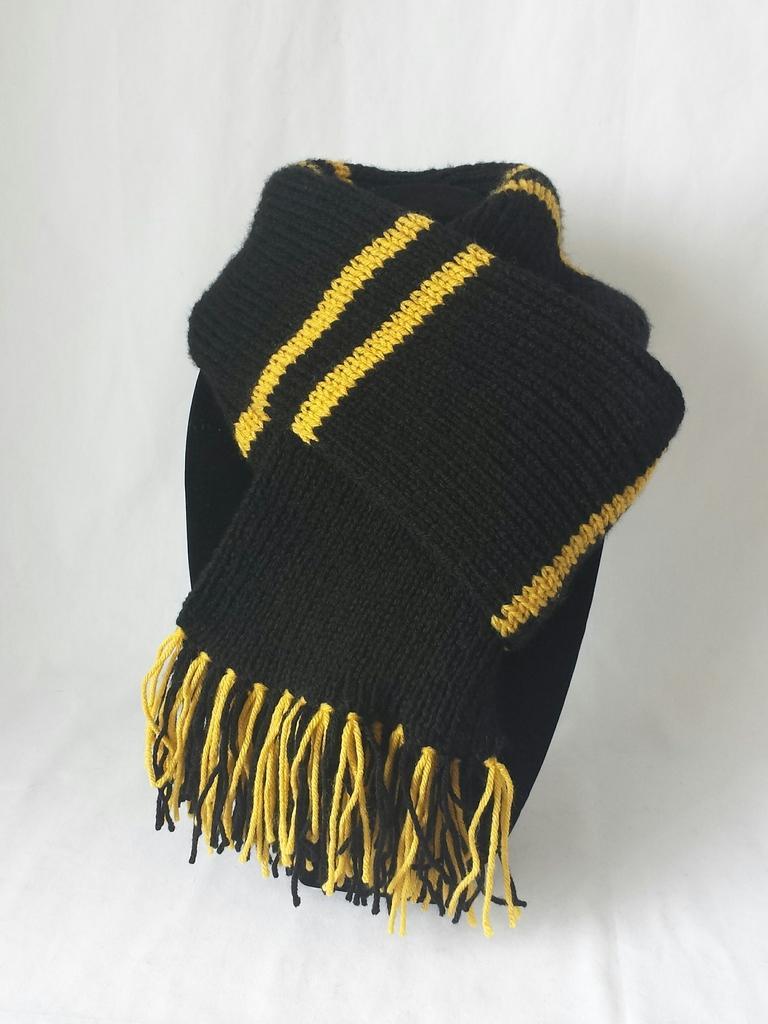Describe this image in one or two sentences. In the center of the image there is a black color scarf on white color surface. 